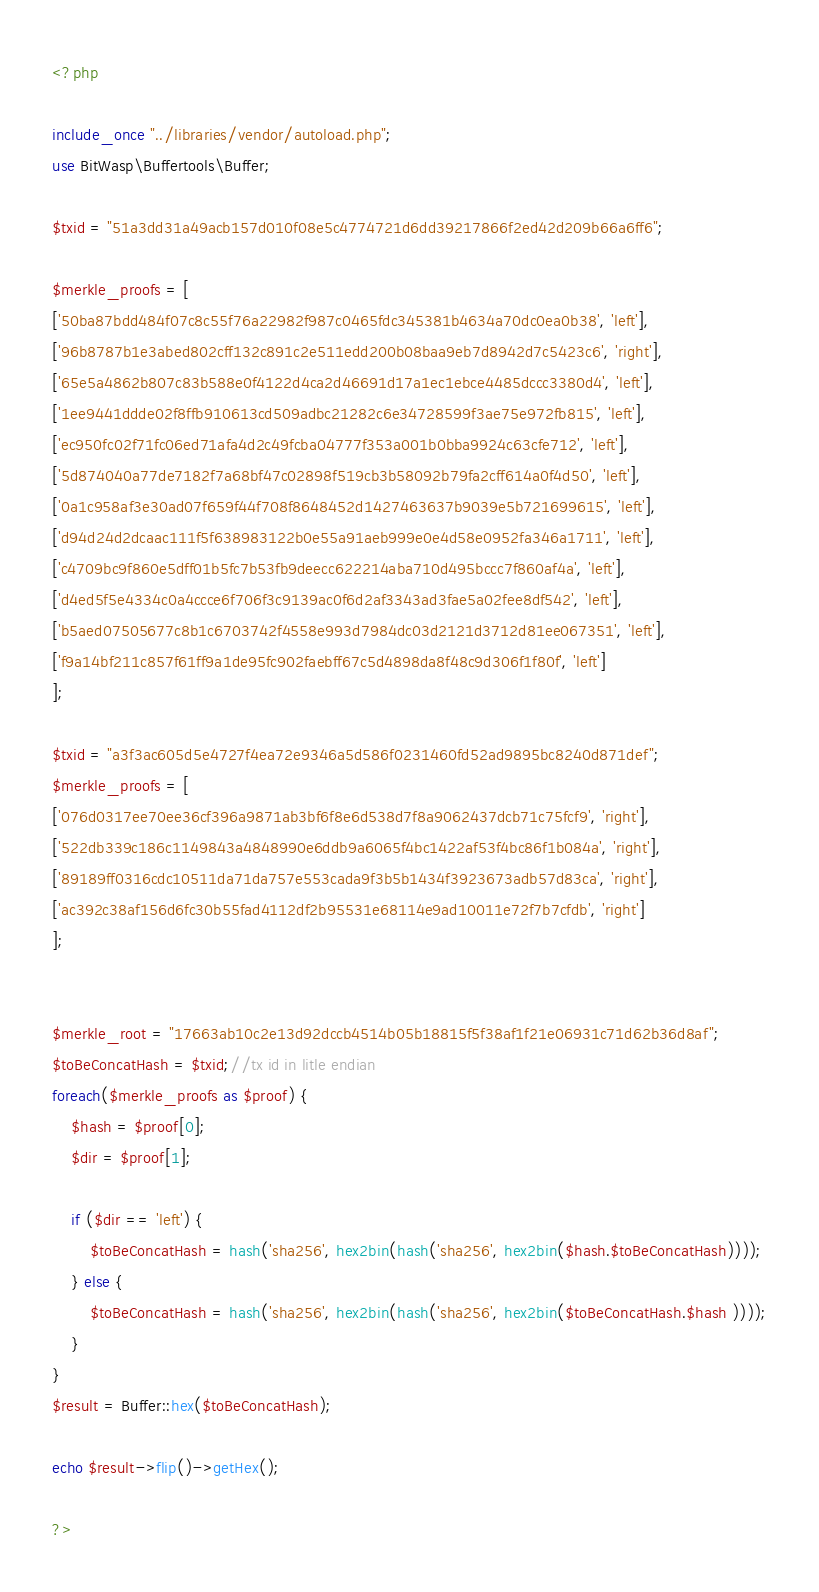<code> <loc_0><loc_0><loc_500><loc_500><_PHP_><?php

include_once "../libraries/vendor/autoload.php";
use BitWasp\Buffertools\Buffer;

$txid = "51a3dd31a49acb157d010f08e5c4774721d6dd39217866f2ed42d209b66a6ff6";

$merkle_proofs = [
['50ba87bdd484f07c8c55f76a22982f987c0465fdc345381b4634a70dc0ea0b38', 'left'],
['96b8787b1e3abed802cff132c891c2e511edd200b08baa9eb7d8942d7c5423c6', 'right'],
['65e5a4862b807c83b588e0f4122d4ca2d46691d17a1ec1ebce4485dccc3380d4', 'left'],
['1ee9441ddde02f8ffb910613cd509adbc21282c6e34728599f3ae75e972fb815', 'left'],
['ec950fc02f71fc06ed71afa4d2c49fcba04777f353a001b0bba9924c63cfe712', 'left'],
['5d874040a77de7182f7a68bf47c02898f519cb3b58092b79fa2cff614a0f4d50', 'left'],
['0a1c958af3e30ad07f659f44f708f8648452d1427463637b9039e5b721699615', 'left'],
['d94d24d2dcaac111f5f638983122b0e55a91aeb999e0e4d58e0952fa346a1711', 'left'],
['c4709bc9f860e5dff01b5fc7b53fb9deecc622214aba710d495bccc7f860af4a', 'left'],
['d4ed5f5e4334c0a4ccce6f706f3c9139ac0f6d2af3343ad3fae5a02fee8df542', 'left'],
['b5aed07505677c8b1c6703742f4558e993d7984dc03d2121d3712d81ee067351', 'left'],
['f9a14bf211c857f61ff9a1de95fc902faebff67c5d4898da8f48c9d306f1f80f', 'left']
];

$txid = "a3f3ac605d5e4727f4ea72e9346a5d586f0231460fd52ad9895bc8240d871def";
$merkle_proofs = [
['076d0317ee70ee36cf396a9871ab3bf6f8e6d538d7f8a9062437dcb71c75fcf9', 'right'],
['522db339c186c1149843a4848990e6ddb9a6065f4bc1422af53f4bc86f1b084a', 'right'],
['89189ff0316cdc10511da71da757e553cada9f3b5b1434f3923673adb57d83ca', 'right'],
['ac392c38af156d6fc30b55fad4112df2b95531e68114e9ad10011e72f7b7cfdb', 'right']
];


$merkle_root = "17663ab10c2e13d92dccb4514b05b18815f5f38af1f21e06931c71d62b36d8af";
$toBeConcatHash = $txid;//tx id in litle endian
foreach($merkle_proofs as $proof) {
	$hash = $proof[0];
	$dir = $proof[1];
	
	if ($dir == 'left') {
		$toBeConcatHash = hash('sha256', hex2bin(hash('sha256', hex2bin($hash.$toBeConcatHash))));
	} else {
		$toBeConcatHash = hash('sha256', hex2bin(hash('sha256', hex2bin($toBeConcatHash.$hash ))));
	}
}
$result = Buffer::hex($toBeConcatHash);

echo $result->flip()->getHex();

?></code> 